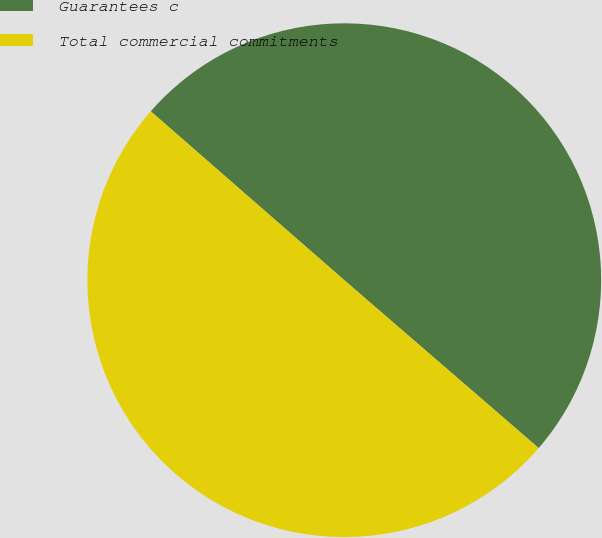<chart> <loc_0><loc_0><loc_500><loc_500><pie_chart><fcel>Guarantees c<fcel>Total commercial commitments<nl><fcel>49.92%<fcel>50.08%<nl></chart> 